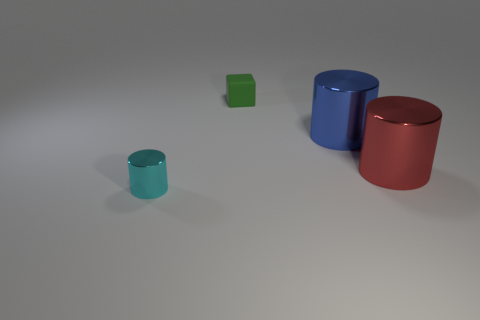Can you describe the texture of the surfaces in the image? The cylinders have a smooth, glossy finish, reflecting light and giving them a polished look. The surface they rest on appears matte and less reflective, providing a contrast between the objects and the ground. 